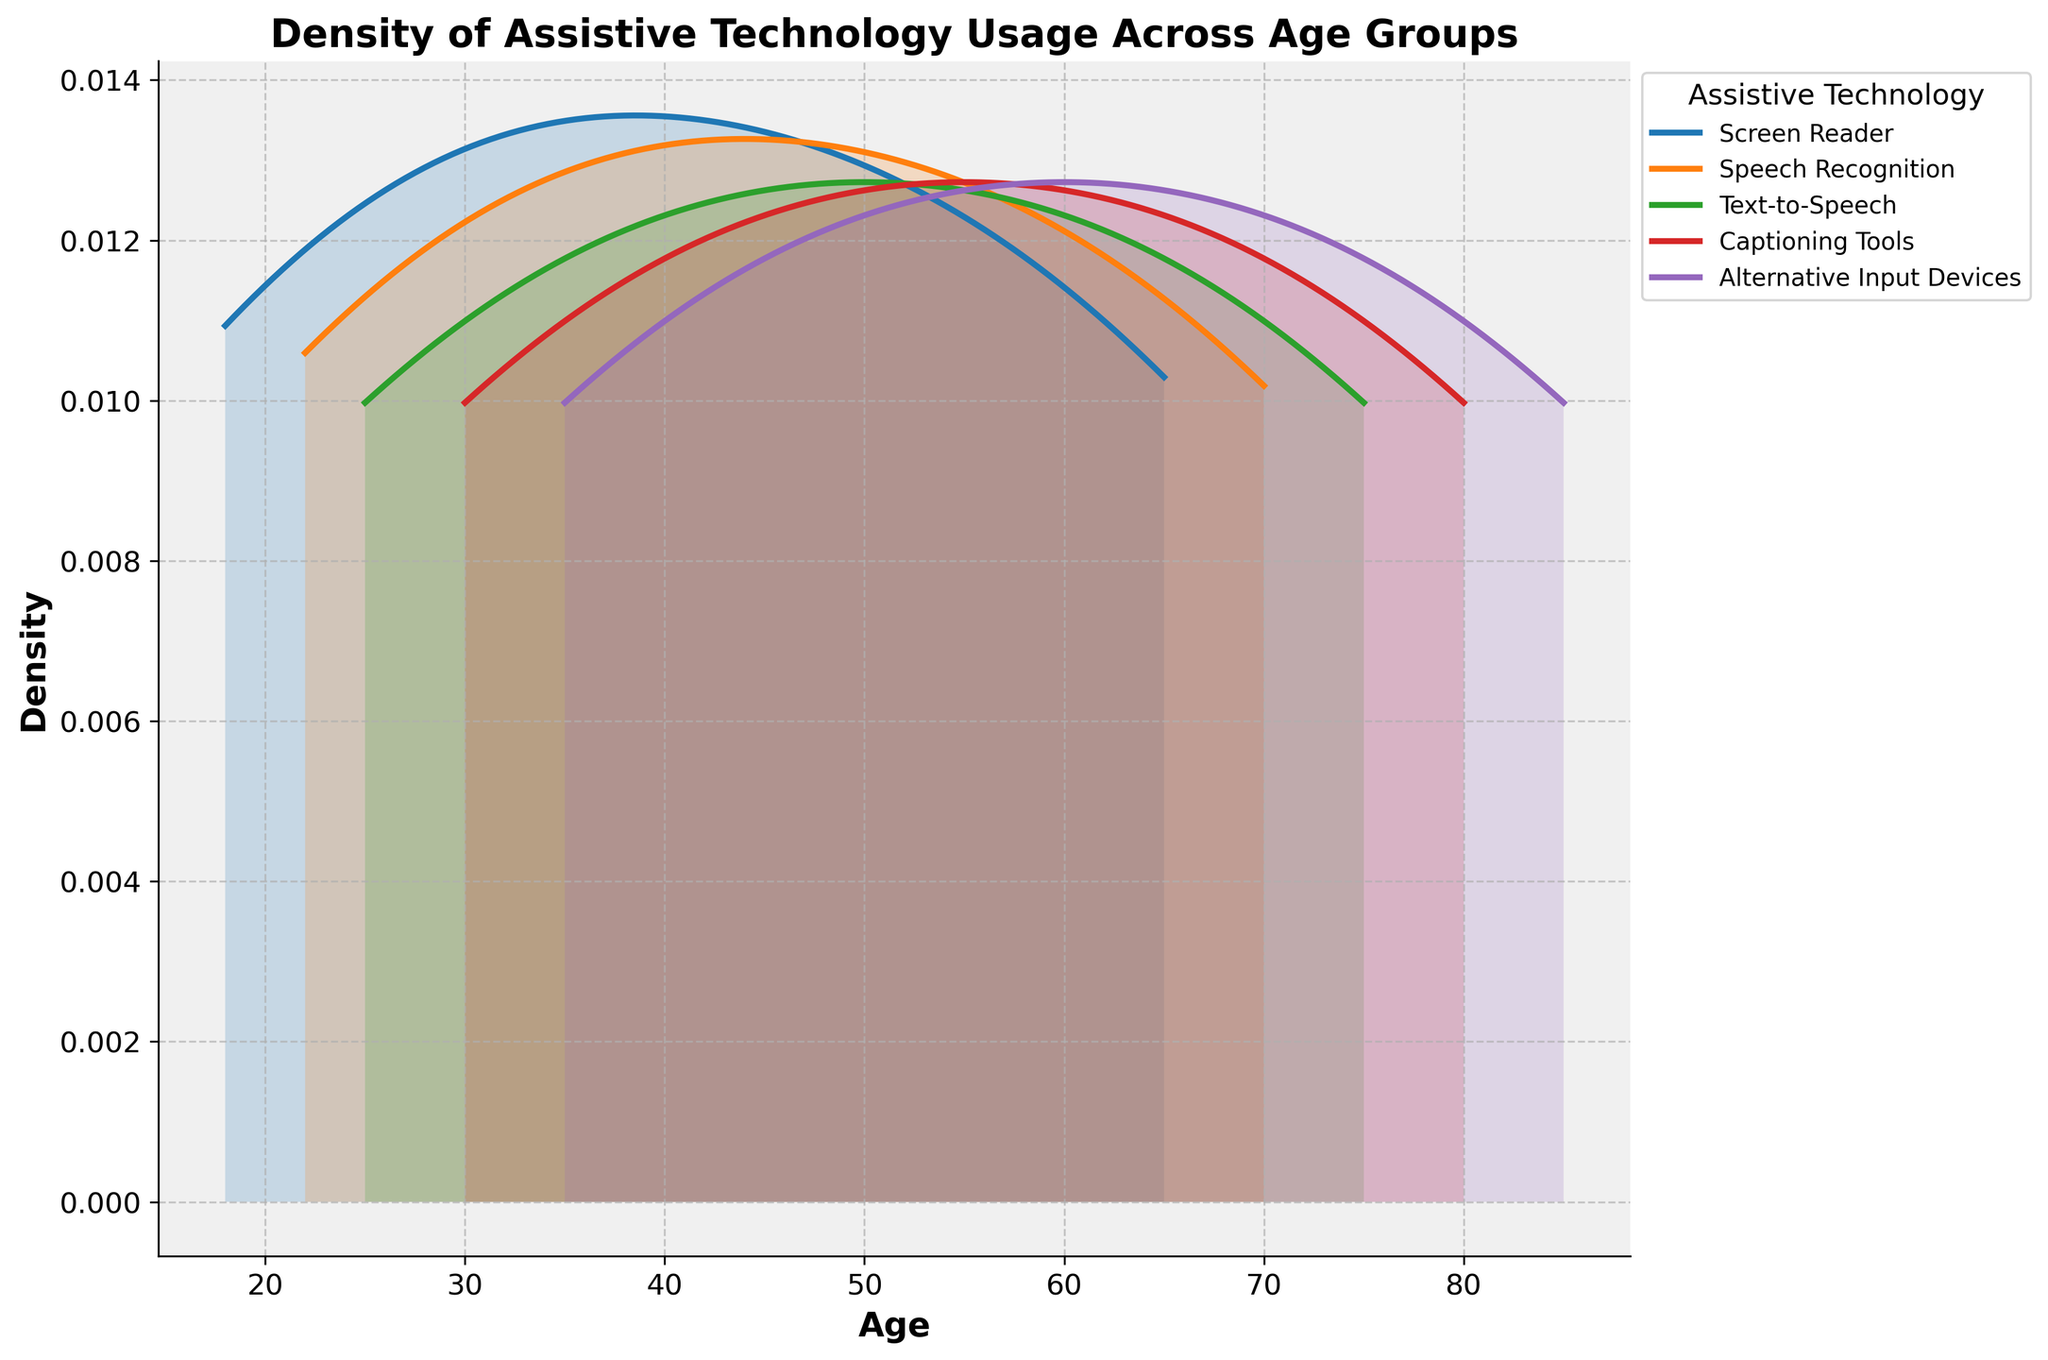What's the title of the figure? The title is usually the text at the top of the plot. In this case, it's labeled as the 'Density of Assistive Technology Usage Across Age Groups'.
Answer: Density of Assistive Technology Usage Across Age Groups What ages does the plot's x-axis cover? To find the range of ages, look at the x-axis's start and end points. The plot spans from approximately 18 to 85 years old.
Answer: Approximately 18 to 85 years old Which assistive technology shows the highest density peak? By observing the plot, locate the curve that reaches the highest point along the y-axis. The 'Captioning Tools' curve has the highest peak density.
Answer: Captioning Tools How does the density of 'Screen Reader' usage change across age? Identify the 'Screen Reader' curve and describe its trend: it starts lower, increases around middle-aged groups, and peaks towards older ages.
Answer: Increases and peaks towards older ages Which two age groups show the highest density for 'Text-to-Speech' usage? Locate the 'Text-to-Speech' curve and find the ages where it reaches its highest values. The highest densities occur around ages 50 and 75.
Answer: Ages 50 and 75 Is the density of 'Speech Recognition' higher in younger or older age groups? Examine the 'Speech Recognition' curve and compare its density values across different age ranges. It rises towards older age groups.
Answer: Older age groups What's the average age range for 'Alternative Input Devices' usage? To estimate the average, look at where the 'Alternative Input Devices' curve is most dense and spans across. It is densest between ages 35 and 85.
Answer: Between ages 35 and 85 Which technology shows a declining usage density with age? Check each curve's trend; 'Speech Recognition' shows a more varied pattern but generally declines after peaking.
Answer: Speech Recognition Among age groups 40 and 50, which assistive technology has the highest usage density? Look between the ages 40 and 50 on the x-axis and find the highest curve within the specified range. 'Text-to-Speech' has the highest density.
Answer: Text-to-Speech What can you infer about the diversity of assistive technology usage across different age groups? Examine the plot's overall distribution: various technologies peak at different age ranges, indicating diverse preferences and needs in assistive technology usage.
Answer: Diverse preferences and needs across ages 